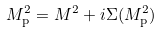Convert formula to latex. <formula><loc_0><loc_0><loc_500><loc_500>M _ { \text  p}^{2} = M^{2} + i\Sigma(M_{\text  p}^{2})</formula> 